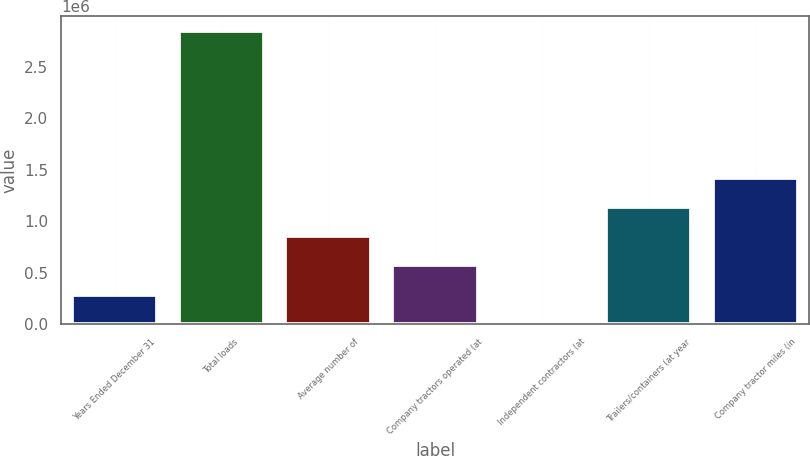<chart> <loc_0><loc_0><loc_500><loc_500><bar_chart><fcel>Years Ended December 31<fcel>Total loads<fcel>Average number of<fcel>Company tractors operated (at<fcel>Independent contractors (at<fcel>Trailers/containers (at year<fcel>Company tractor miles (in<nl><fcel>285349<fcel>2.84738e+06<fcel>854688<fcel>570019<fcel>679<fcel>1.13936e+06<fcel>1.42403e+06<nl></chart> 